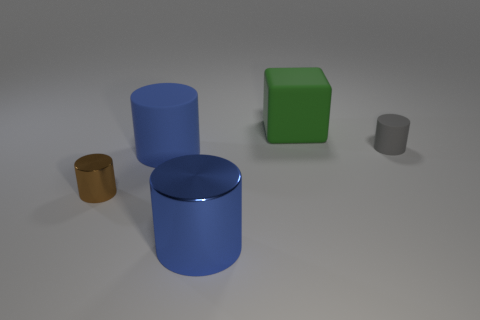Add 4 metal cylinders. How many objects exist? 9 Subtract all small matte cylinders. How many cylinders are left? 3 Subtract all blue cylinders. How many cylinders are left? 2 Subtract 4 cylinders. How many cylinders are left? 0 Add 5 brown shiny objects. How many brown shiny objects exist? 6 Subtract 0 cyan blocks. How many objects are left? 5 Subtract all cylinders. How many objects are left? 1 Subtract all blue cylinders. Subtract all yellow spheres. How many cylinders are left? 2 Subtract all brown cubes. How many gray cylinders are left? 1 Subtract all small metallic cylinders. Subtract all big blue metal cylinders. How many objects are left? 3 